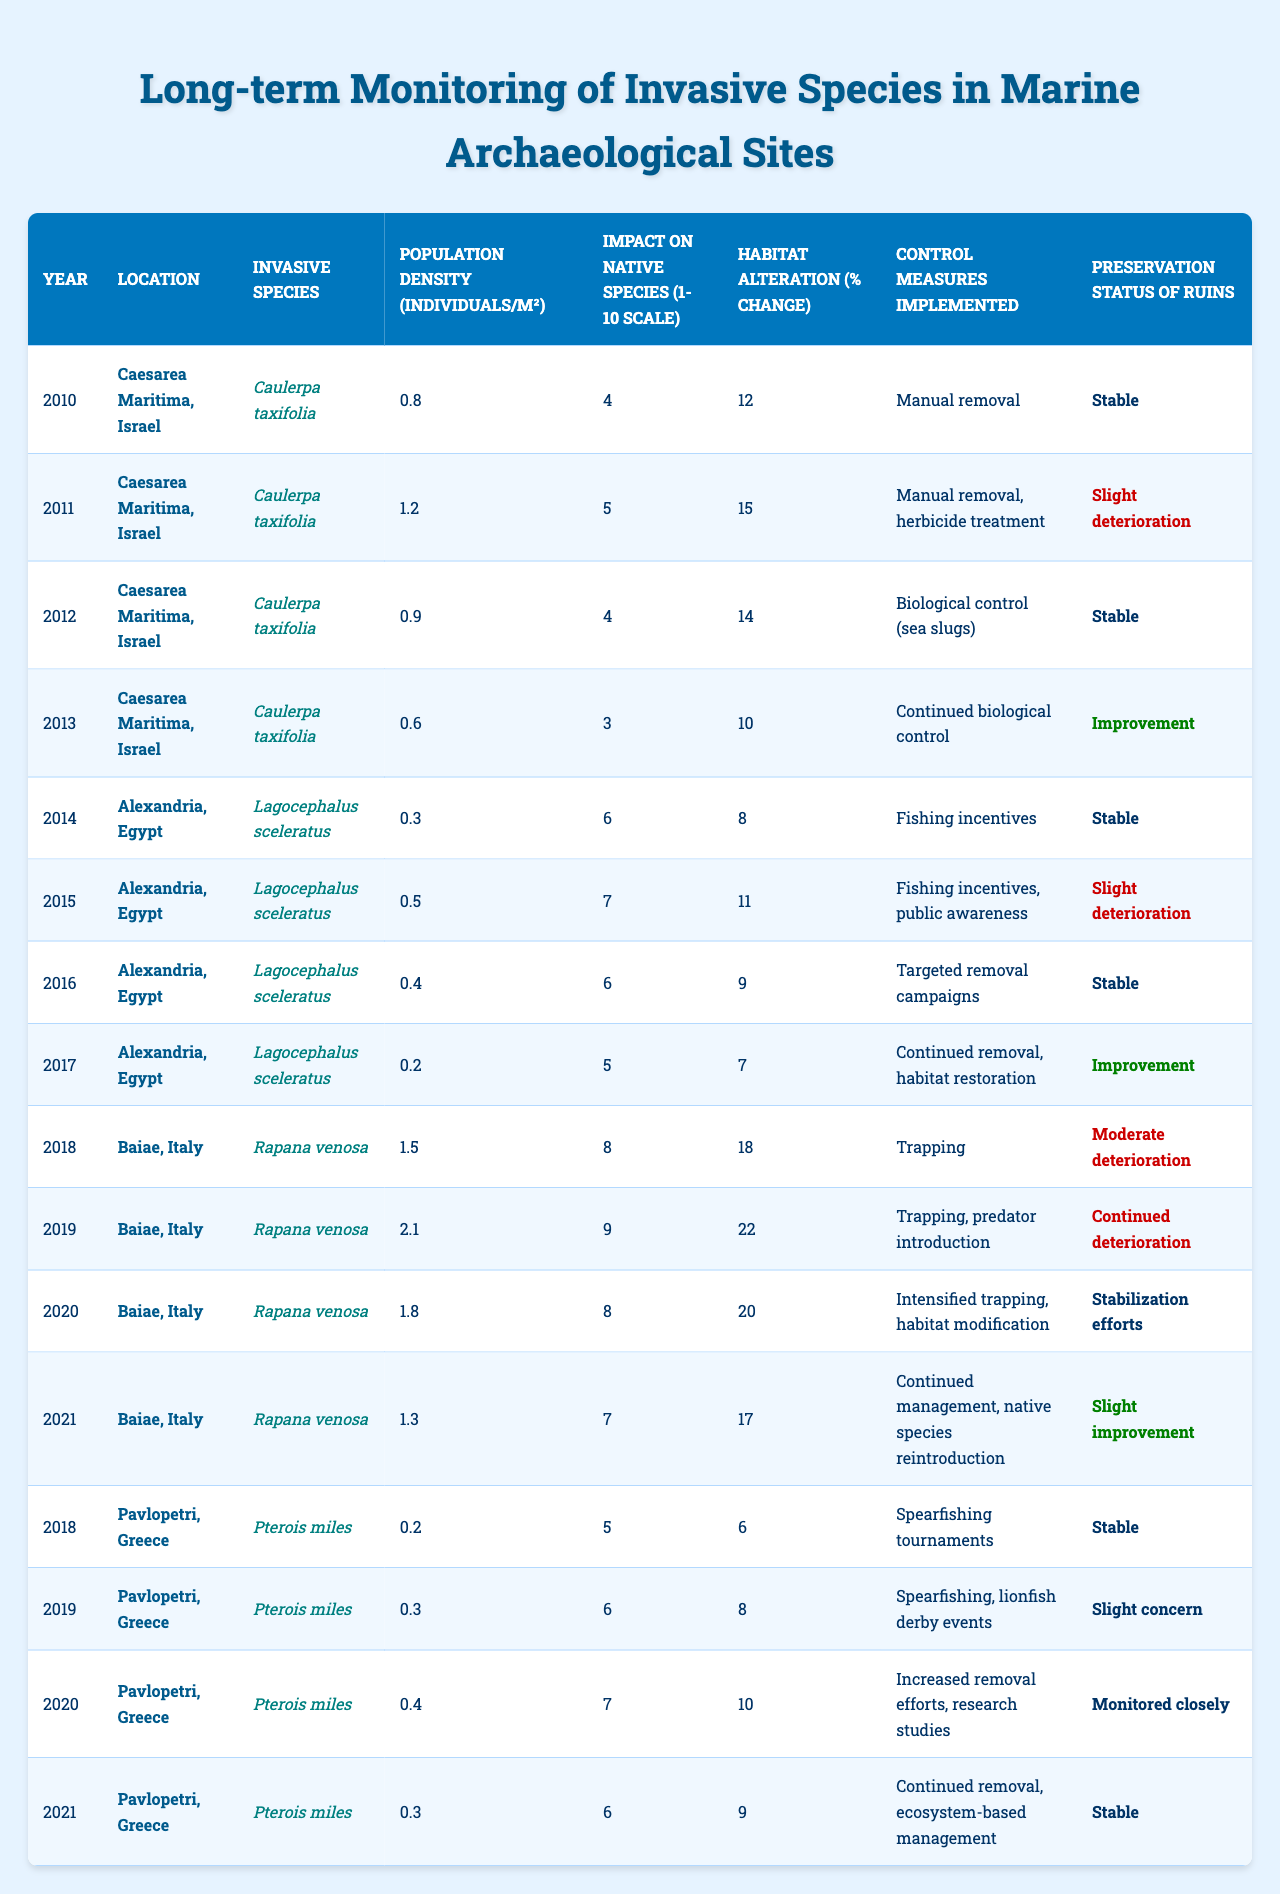What is the population density of "Caulerpa taxifolia" in the year 2011 at Caesarea Maritima, Israel? The table shows that in 2011, the population density of "Caulerpa taxifolia" at Caesarea Maritima, Israel was 1.2 individuals/m².
Answer: 1.2 individuals/m² What was the control measure implemented for "Rapana venosa" in 2020 at Baiae, Italy? According to the table, the control measures implemented for "Rapana venosa" in 2020 were intensified trapping and habitat modification.
Answer: Intensified trapping and habitat modification What impact score did "Pterois miles" receive in the year 2020 at Pavlopetri, Greece? The table indicates that in 2020, "Pterois miles" received an impact score of 7 on a scale of 1 to 10.
Answer: 7 What was the average habitat alteration percentage for "Lagocephalus sceleratus" over the years recorded? The habitat alteration percentages for "Lagocephalus sceleratus" are obtained from the years 2014 (8%), 2015 (11%), 2016 (9%), and 2017 (7%), summing these values gives 8 + 11 + 9 + 7 = 35. There are 4 years, so the average is 35 / 4 = 8.75%.
Answer: 8.75% Did the preservation status of the ruins in Caesarea Maritima ever improve from 2010 to 2013? By examining the table, we find that the preservation status started as "Stable" in 2010, went to "Slight deterioration" in 2011, then returned to "Stable" in 2012, and finally improved to "Improvement" in 2013, indicating an improvement occurred.
Answer: Yes Which location experienced the highest impact score from "Rapana venosa" and what was the score? Looking at the impact scores for "Rapana venosa," Baiae, Italy had scores of 8 (2018), 9 (2019), 8 (2020), and 7 (2021). The highest score was 9 in the year 2019.
Answer: Baiae, Italy, score 9 What is the trend in the population density of "Caulerpa taxifolia" from 2010 to 2013? From the data, "Caulerpa taxifolia" showed a decrease in population density from 0.8 in 2010 to 1.2 in 2011, then declined to 0.9 in 2012, and finally dropped further to 0.6 in 2013, indicating a downward trend overall.
Answer: Decreasing trend How many times was manual removal employed as a control measure in the table? By analyzing the data, manual removal was listed as a control measure in 2010, 2011, 2012, and not explicitly in 2013, as it changed to biological control; therefore, it was used 3 times.
Answer: 3 times What is the population density average of "Pterois miles" across all recorded years? Calculating the population densities for "Pterois miles" gives 0.2 (2018), 0.3 (2019), 0.4 (2020), and 0.3 (2021). The sum is 0.2 + 0.3 + 0.4 + 0.3 = 1.2, and dividing by the 4 years gives an average of 1.2 / 4 = 0.3 individuals/m².
Answer: 0.3 individuals/m² 